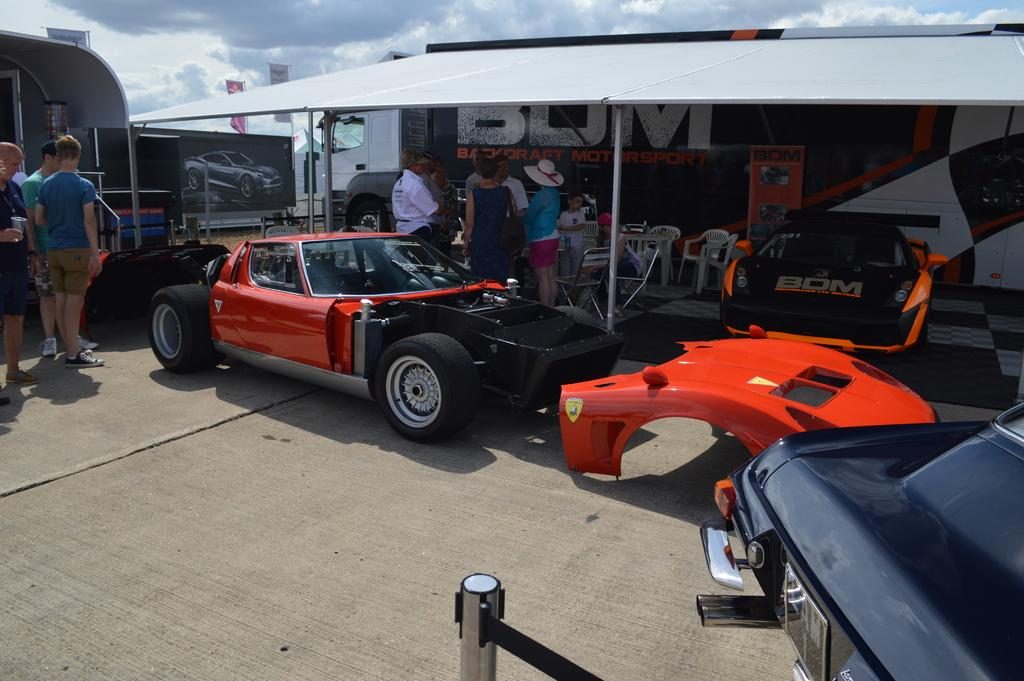What type of vehicles are in the image? There are sports cars in the image. What else can be seen in the image besides the sports cars? There are people standing and chairs visible in the image. What is located in the background of the image? There is a bus and a shed in the background of the image. What is visible at the top of the image? The sky is visible at the top of the image. What objects are made of boards in the image? The boards visible in the image are not specified, but they could be part of the chairs or other structures. How many toes are visible on the people in the image? The number of toes visible on the people in the image cannot be determined from the provided facts, as the focus is on the sports cars and other objects. 